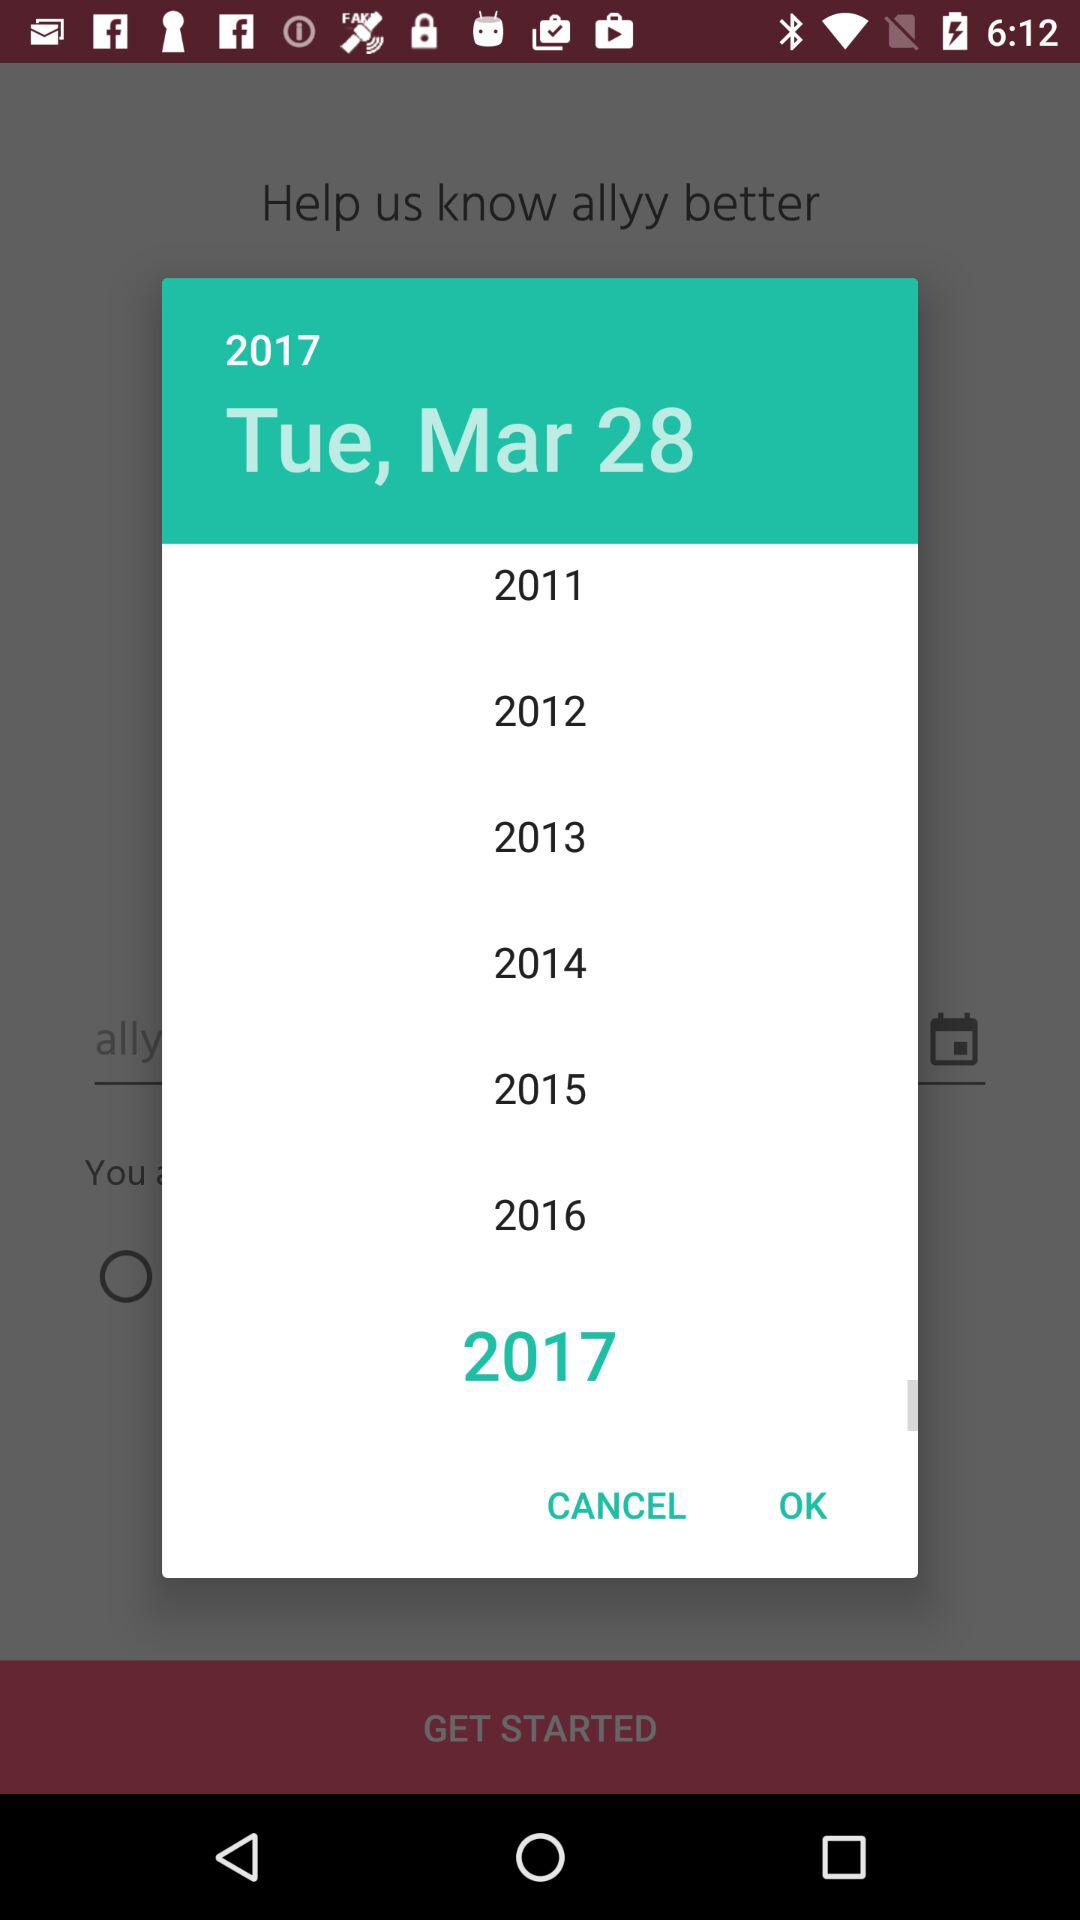What is the selected date? The selected date is Tuesday, March 28, 2017. 